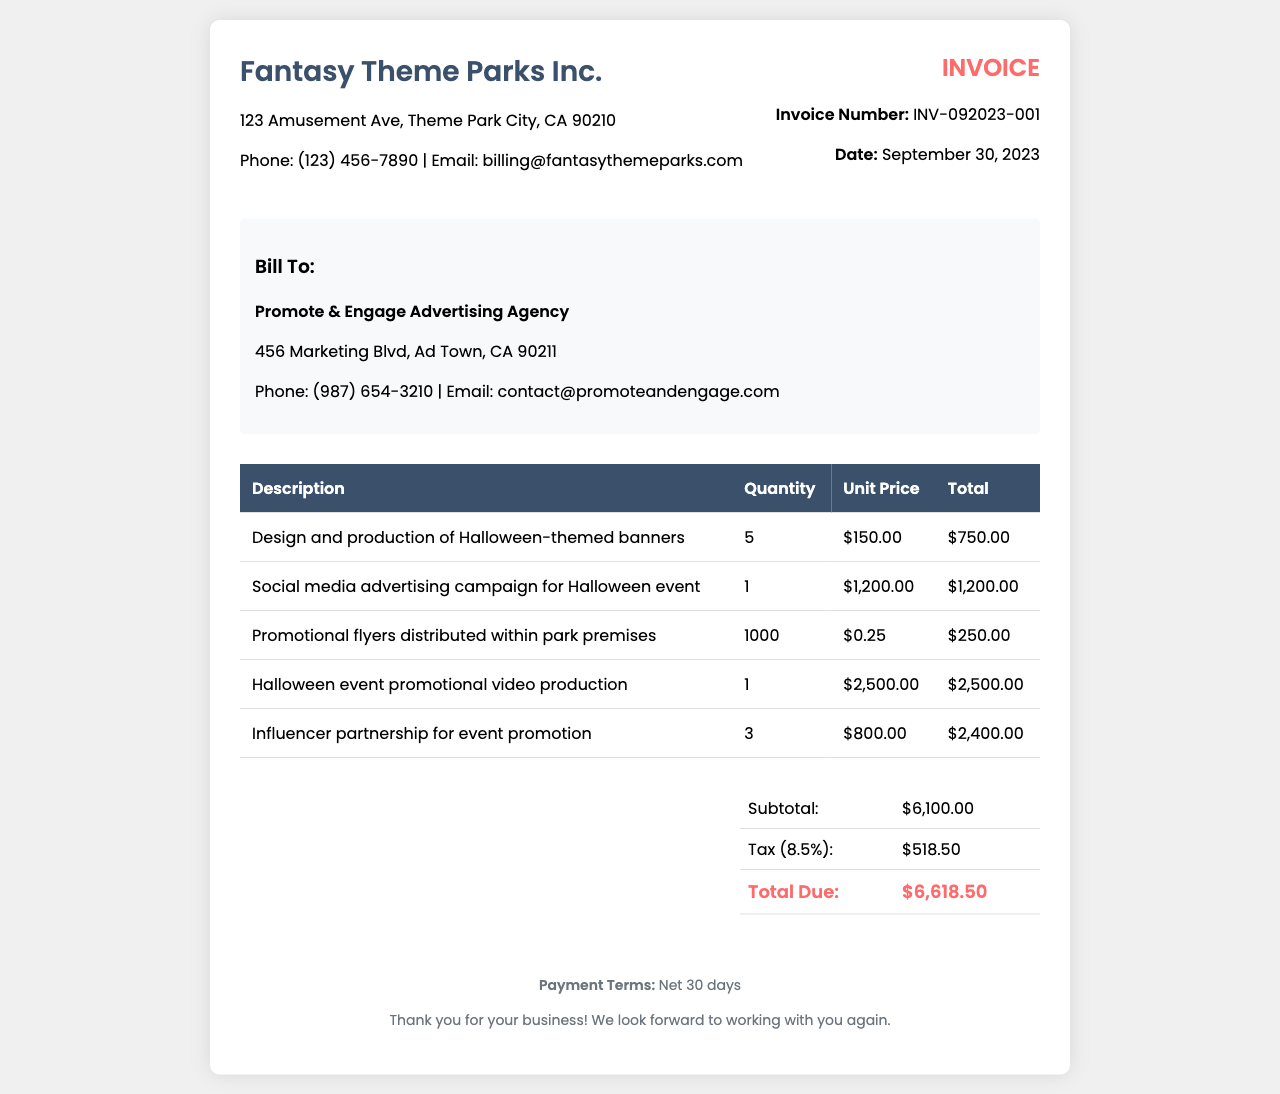what is the invoice number? The invoice number is specified in the invoice details section.
Answer: INV-092023-001 what is the total due amount? The total due amount is indicated in the summary table at the bottom of the invoice.
Answer: $6,618.50 who is the bill recipient? The recipient of the bill is shown in the client info section of the document.
Answer: Promote & Engage Advertising Agency how many Halloween-themed banners were produced? The quantity of Halloween-themed banners is listed in the table under "Quantity."
Answer: 5 what is the tax rate applied to the invoice? The tax rate is provided in the summary section of the invoice, calculated at 8.5%.
Answer: 8.5% what is the date of the invoice? The date of the invoice can be found in the invoice details section.
Answer: September 30, 2023 what services were included in the invoice? The services provided are enumerated in the table under "Description."
Answer: Design and production of Halloween-themed banners, Social media advertising campaign for Halloween event, Promotional flyers distributed within park premises, Halloween event promotional video production, Influencer partnership for event promotion when is the payment due? The payment terms are detailed in the footer of the invoice document.
Answer: Net 30 days what is the subtotal before tax? The subtotal is indicated in the summary table section before the tax is added.
Answer: $6,100.00 